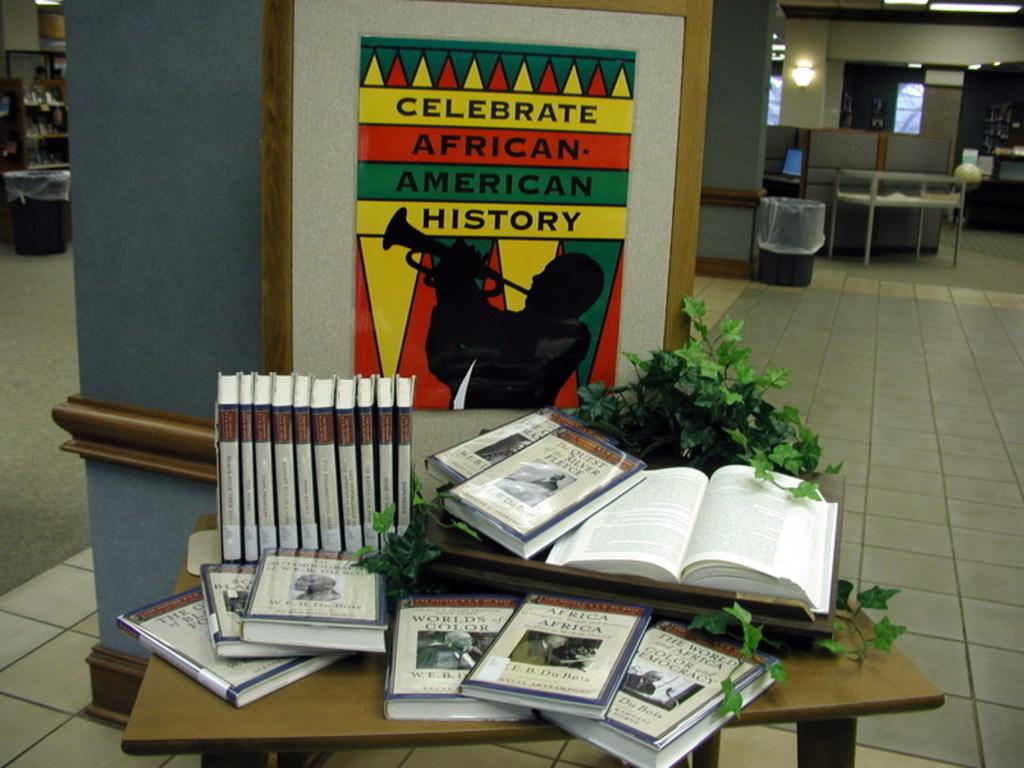<image>
Render a clear and concise summary of the photo. A table of books is set up in honor of African-American history. 